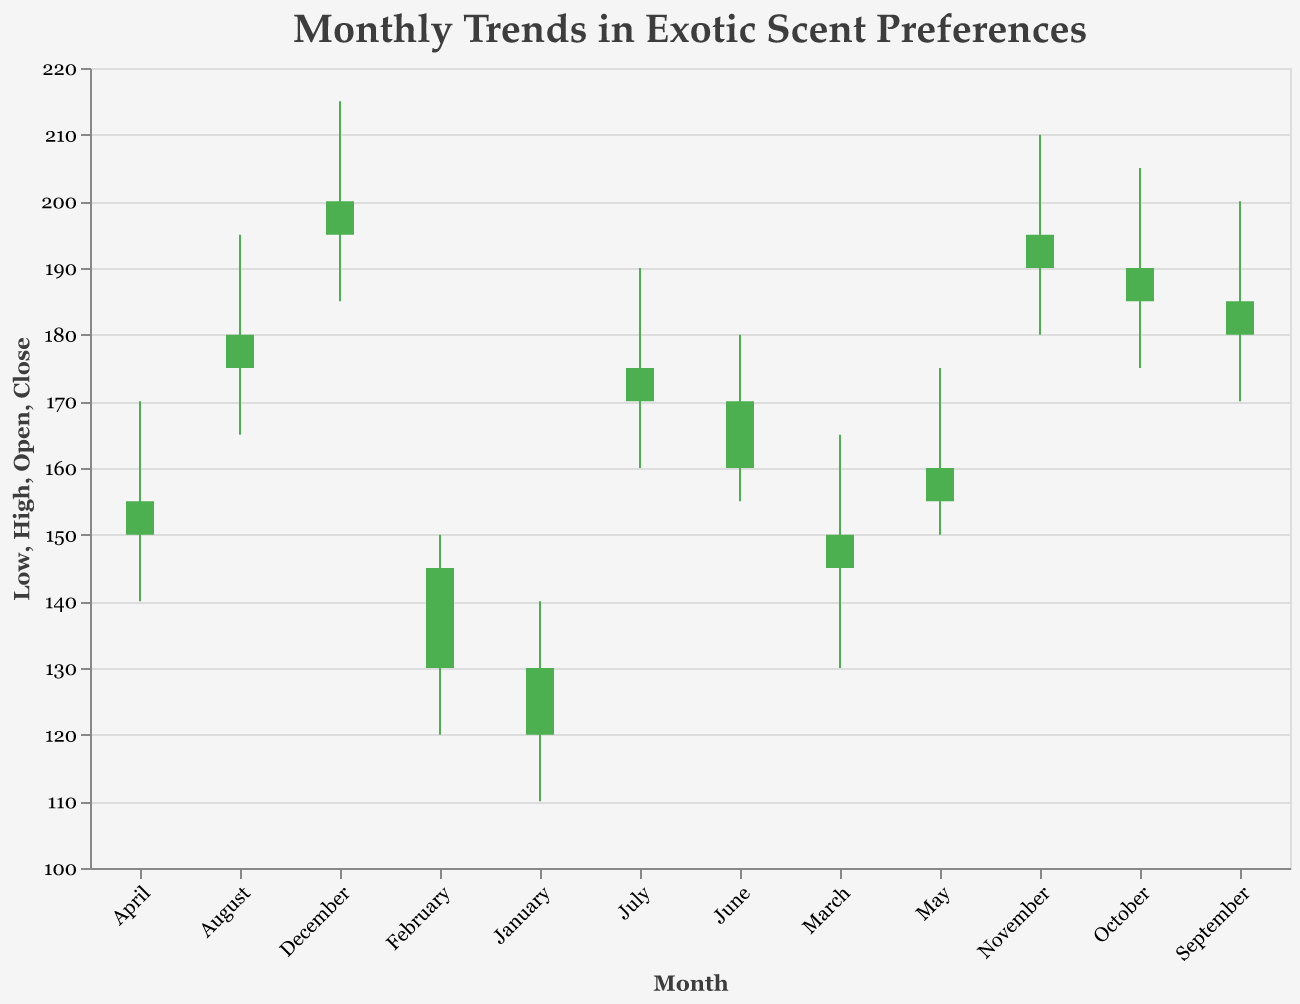What's the most popular scent in January? The graph shows "Vanilla Orchid" corresponding to January in the data.
Answer: Vanilla Orchid Which month had the highest peak sales value, and what was it? October shows the highest peak sales value because it has a high point at 205.
Answer: October, 205 Compare the opening sales values from January to March. Which month had the lowest opening value? January's open value is 120, February is 130, March is 145. January has the lowest opening value.
Answer: January Which months show an increase in scent preference from opening to closing sales? All months where the closing value is greater than the opening value. These months are: January, February, March, April, May, June, July, August, September, October, November, December.
Answer: All months What is the range of sales values for June? The range is from the lowest to the highest value in June, which is 155 to 180. The range is 180 - 155 = 25.
Answer: 25 How does the sales trend of "Citrus Verbena" compare to "Jasmine Breeze"? For "Citrus Verbena" (April), the opening value is 150, the closing is 155, the high is 170, and the low is 140. For "Jasmine Breeze" (March), the opening value is 145, the closing is 150, the high is 165, and the low is 130. Both months show an upward trend, but "Citrus Verbena" has higher overall sales values.
Answer: "Citrus Verbena" has higher values Which scent showed minimal fluctuation in sales and what were its values? Minimal fluctuation is seen where the difference between high and low values is the least. "Jasmine Breeze" (March) has values from 165 to 130, making the fluctuation range 35. Checking all others, we confirm "Jasmine Breeze" has the smallest range.
Answer: Jasmine Breeze, 35 In which months did the lowest sales value exceed 150? Look for months where the 'Low' value is above 150. From the data: May (150), June (155), July (160), August (165), September (170), October (175), November (180), December (185).
Answer: June to December Adding all the highest sales values for March, July, and November, what's the total? The high sales values for March, July, and November are 165, 190, and 210. Sum these values: 165 + 190 + 210 = 565.
Answer: 565 